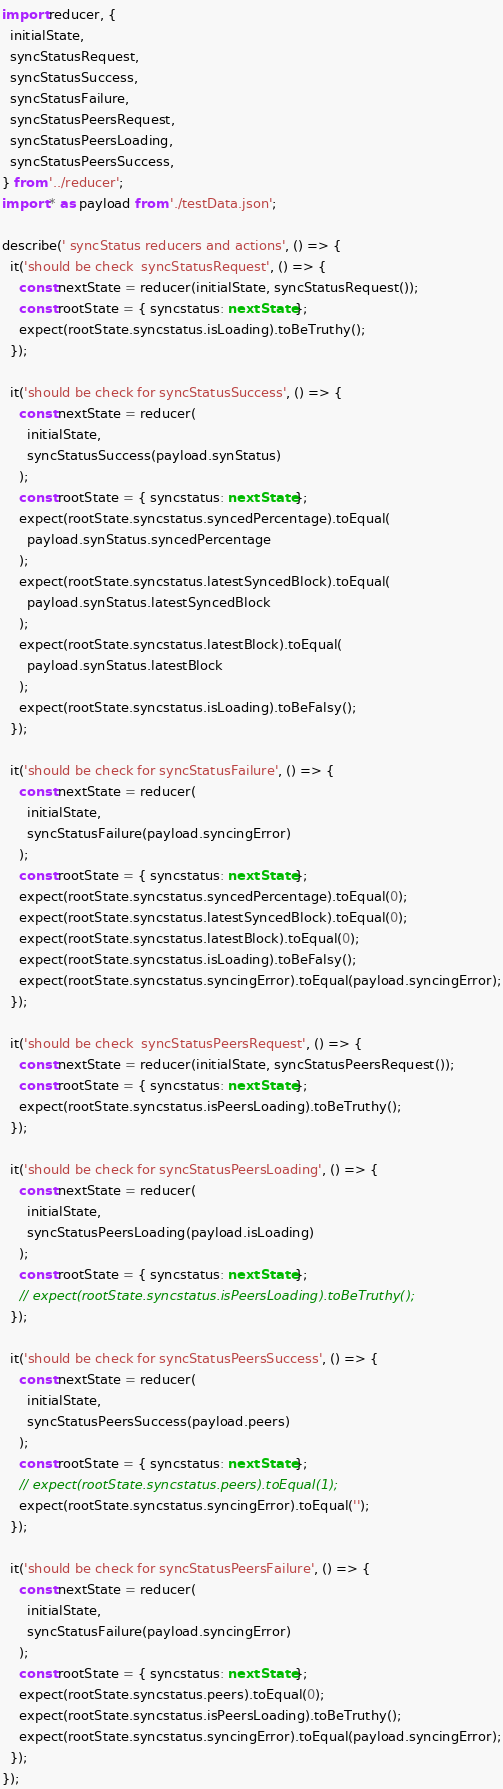<code> <loc_0><loc_0><loc_500><loc_500><_TypeScript_>import reducer, {
  initialState,
  syncStatusRequest,
  syncStatusSuccess,
  syncStatusFailure,
  syncStatusPeersRequest,
  syncStatusPeersLoading,
  syncStatusPeersSuccess,
} from '../reducer';
import * as payload from './testData.json';

describe(' syncStatus reducers and actions', () => {
  it('should be check  syncStatusRequest', () => {
    const nextState = reducer(initialState, syncStatusRequest());
    const rootState = { syncstatus: nextState };
    expect(rootState.syncstatus.isLoading).toBeTruthy();
  });

  it('should be check for syncStatusSuccess', () => {
    const nextState = reducer(
      initialState,
      syncStatusSuccess(payload.synStatus)
    );
    const rootState = { syncstatus: nextState };
    expect(rootState.syncstatus.syncedPercentage).toEqual(
      payload.synStatus.syncedPercentage
    );
    expect(rootState.syncstatus.latestSyncedBlock).toEqual(
      payload.synStatus.latestSyncedBlock
    );
    expect(rootState.syncstatus.latestBlock).toEqual(
      payload.synStatus.latestBlock
    );
    expect(rootState.syncstatus.isLoading).toBeFalsy();
  });

  it('should be check for syncStatusFailure', () => {
    const nextState = reducer(
      initialState,
      syncStatusFailure(payload.syncingError)
    );
    const rootState = { syncstatus: nextState };
    expect(rootState.syncstatus.syncedPercentage).toEqual(0);
    expect(rootState.syncstatus.latestSyncedBlock).toEqual(0);
    expect(rootState.syncstatus.latestBlock).toEqual(0);
    expect(rootState.syncstatus.isLoading).toBeFalsy();
    expect(rootState.syncstatus.syncingError).toEqual(payload.syncingError);
  });

  it('should be check  syncStatusPeersRequest', () => {
    const nextState = reducer(initialState, syncStatusPeersRequest());
    const rootState = { syncstatus: nextState };
    expect(rootState.syncstatus.isPeersLoading).toBeTruthy();
  });

  it('should be check for syncStatusPeersLoading', () => {
    const nextState = reducer(
      initialState,
      syncStatusPeersLoading(payload.isLoading)
    );
    const rootState = { syncstatus: nextState };
    // expect(rootState.syncstatus.isPeersLoading).toBeTruthy();
  });

  it('should be check for syncStatusPeersSuccess', () => {
    const nextState = reducer(
      initialState,
      syncStatusPeersSuccess(payload.peers)
    );
    const rootState = { syncstatus: nextState };
    // expect(rootState.syncstatus.peers).toEqual(1);
    expect(rootState.syncstatus.syncingError).toEqual('');
  });

  it('should be check for syncStatusPeersFailure', () => {
    const nextState = reducer(
      initialState,
      syncStatusFailure(payload.syncingError)
    );
    const rootState = { syncstatus: nextState };
    expect(rootState.syncstatus.peers).toEqual(0);
    expect(rootState.syncstatus.isPeersLoading).toBeTruthy();
    expect(rootState.syncstatus.syncingError).toEqual(payload.syncingError);
  });
});
</code> 